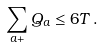<formula> <loc_0><loc_0><loc_500><loc_500>\sum _ { a + } Q _ { a } \leq 6 T \, .</formula> 